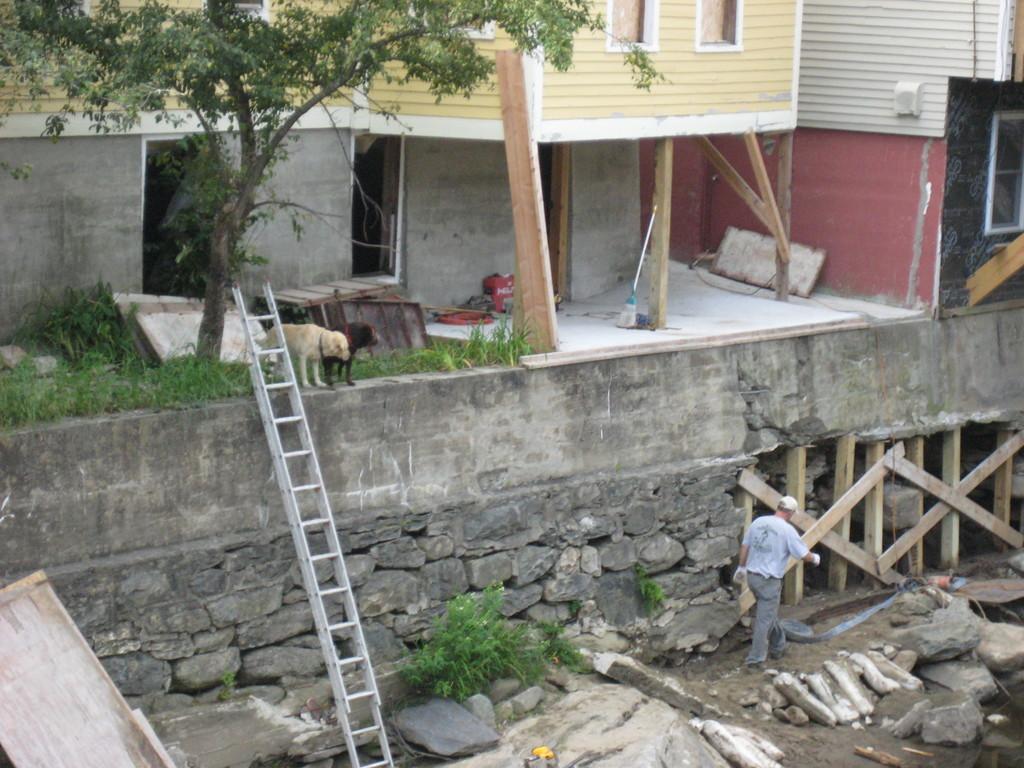Please provide a concise description of this image. In this picture I can see at the bottom there are ladders, on the right side there is a man, he is walking. In the middle there are dogs and there is a tree, in the background there are buildings. 